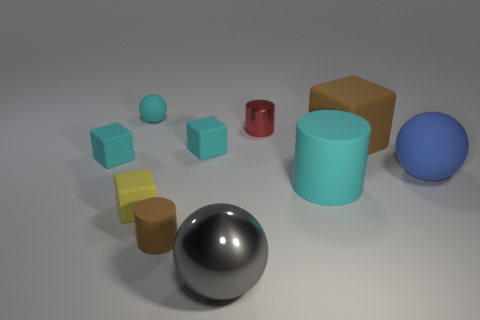Do the big matte block and the tiny matte cylinder have the same color?
Keep it short and to the point. Yes. What number of other objects are there of the same color as the large cube?
Offer a terse response. 1. What number of blocks are big blue rubber things or tiny things?
Give a very brief answer. 3. What number of red cylinders have the same size as the brown cylinder?
Keep it short and to the point. 1. There is a big thing that is in front of the big cyan matte cylinder; how many shiny things are behind it?
Make the answer very short. 1. How big is the thing that is both right of the tiny brown rubber cylinder and in front of the yellow rubber thing?
Offer a very short reply. Large. Are there more large shiny spheres than things?
Your answer should be very brief. No. Are there any large rubber spheres that have the same color as the shiny sphere?
Your answer should be compact. No. Do the matte ball that is on the right side of the brown matte cylinder and the big metal ball have the same size?
Make the answer very short. Yes. Are there fewer small blocks than cyan rubber cylinders?
Provide a short and direct response. No. 